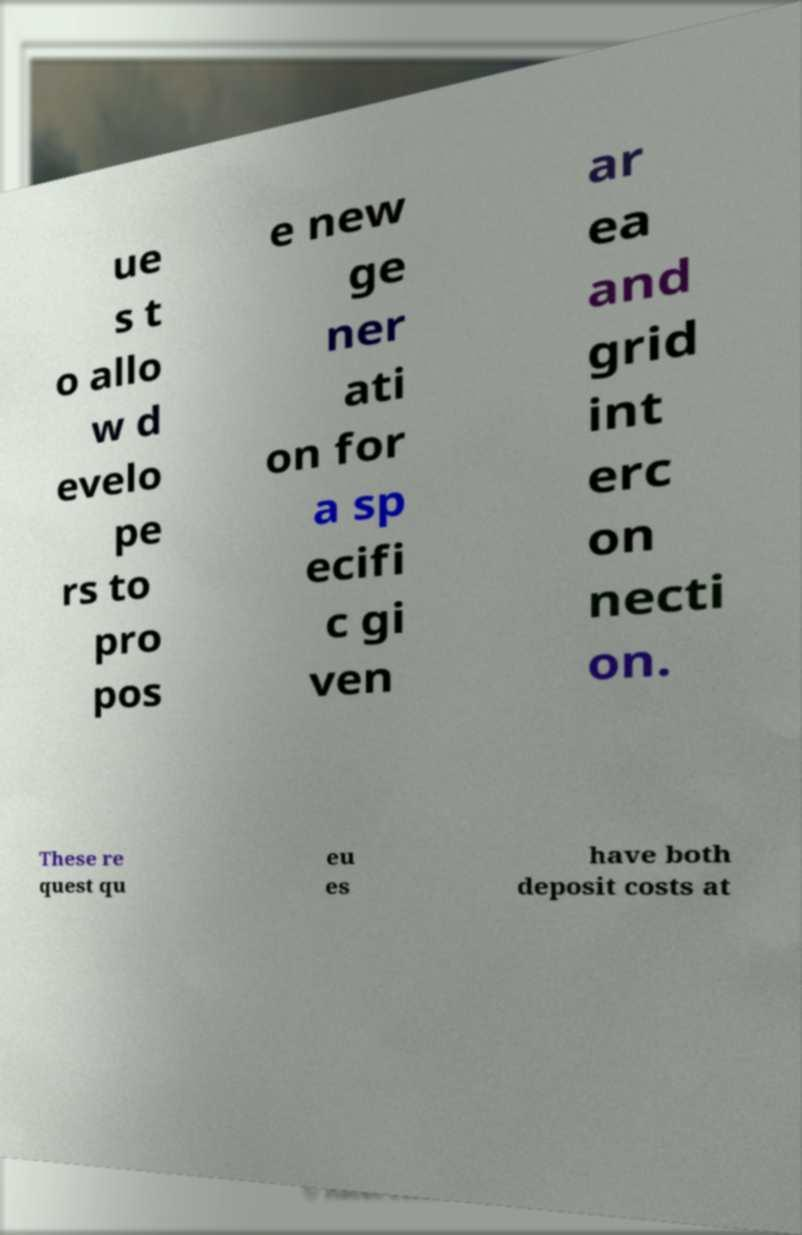Please read and relay the text visible in this image. What does it say? ue s t o allo w d evelo pe rs to pro pos e new ge ner ati on for a sp ecifi c gi ven ar ea and grid int erc on necti on. These re quest qu eu es have both deposit costs at 